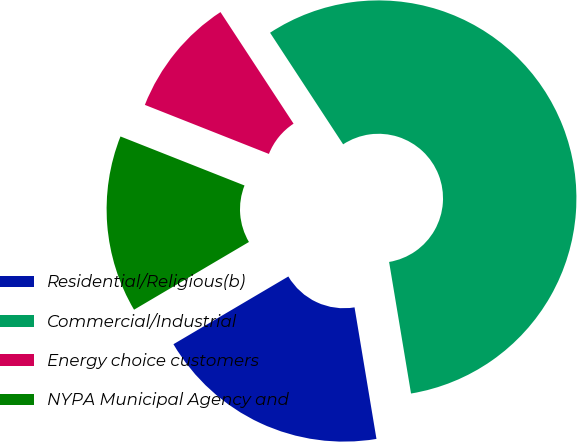<chart> <loc_0><loc_0><loc_500><loc_500><pie_chart><fcel>Residential/Religious(b)<fcel>Commercial/Industrial<fcel>Energy choice customers<fcel>NYPA Municipal Agency and<nl><fcel>19.15%<fcel>56.6%<fcel>9.78%<fcel>14.47%<nl></chart> 